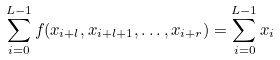<formula> <loc_0><loc_0><loc_500><loc_500>\sum _ { i = 0 } ^ { L - 1 } f ( x _ { i + l } , x _ { i + l + 1 } , \dots , x _ { i + r } ) = \sum _ { i = 0 } ^ { L - 1 } x _ { i }</formula> 